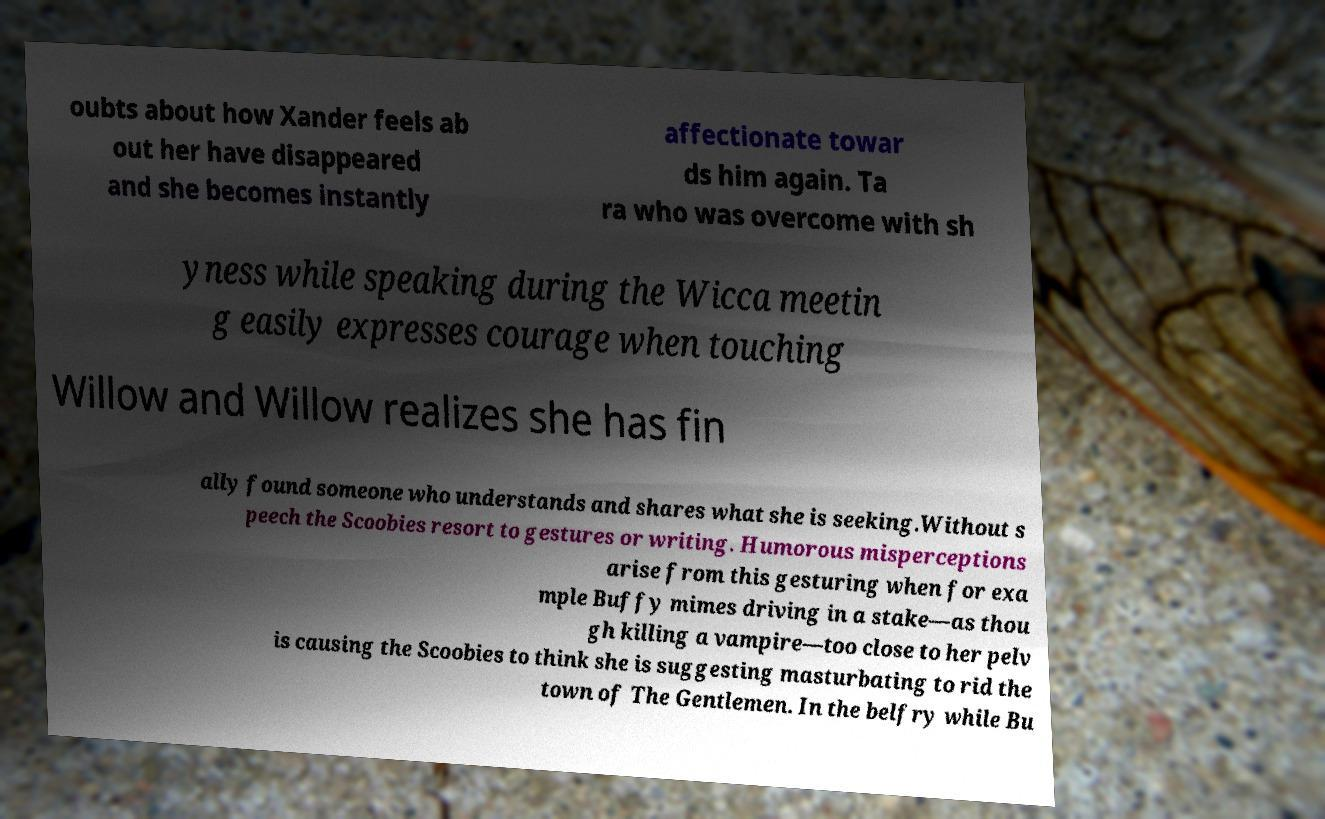Please identify and transcribe the text found in this image. oubts about how Xander feels ab out her have disappeared and she becomes instantly affectionate towar ds him again. Ta ra who was overcome with sh yness while speaking during the Wicca meetin g easily expresses courage when touching Willow and Willow realizes she has fin ally found someone who understands and shares what she is seeking.Without s peech the Scoobies resort to gestures or writing. Humorous misperceptions arise from this gesturing when for exa mple Buffy mimes driving in a stake—as thou gh killing a vampire—too close to her pelv is causing the Scoobies to think she is suggesting masturbating to rid the town of The Gentlemen. In the belfry while Bu 